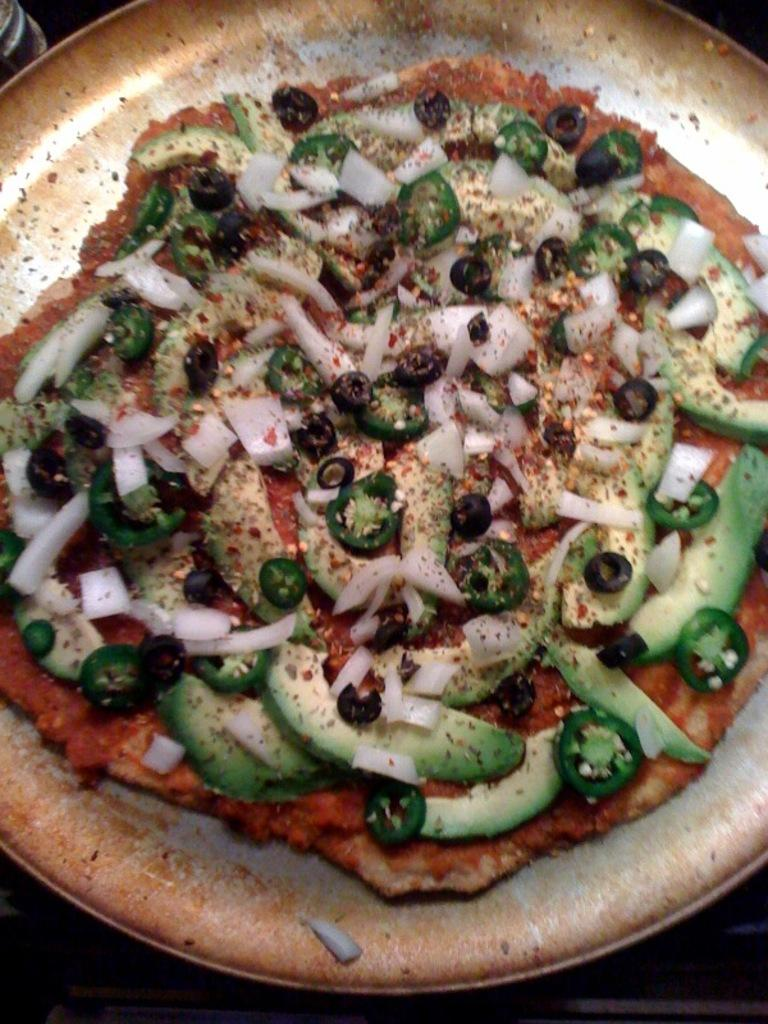What type of food is shown in the image? There is a pizza in the image. What colors can be seen on the pizza? The pizza has cream, red, green, and black colors. On what surface is the pizza placed? The pizza is on some surface. What type of poison is dripping from the pipe in the image? There is no pipe or poison present in the image; it features a pizza with specific colors. 